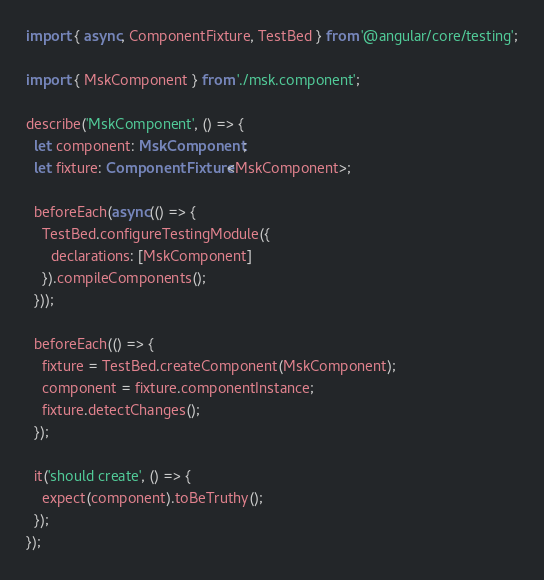<code> <loc_0><loc_0><loc_500><loc_500><_TypeScript_>import { async, ComponentFixture, TestBed } from '@angular/core/testing';

import { MskComponent } from './msk.component';

describe('MskComponent', () => {
  let component: MskComponent;
  let fixture: ComponentFixture<MskComponent>;

  beforeEach(async(() => {
    TestBed.configureTestingModule({
      declarations: [MskComponent]
    }).compileComponents();
  }));

  beforeEach(() => {
    fixture = TestBed.createComponent(MskComponent);
    component = fixture.componentInstance;
    fixture.detectChanges();
  });

  it('should create', () => {
    expect(component).toBeTruthy();
  });
});
</code> 